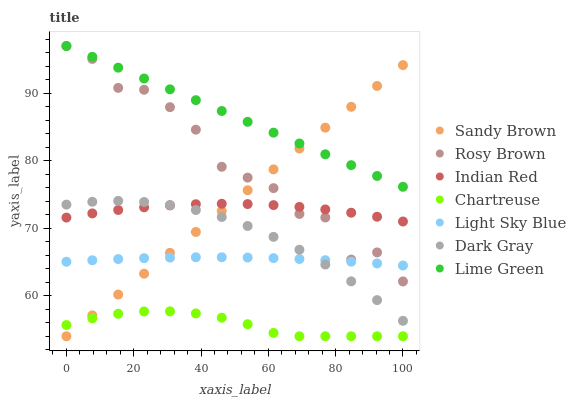Does Chartreuse have the minimum area under the curve?
Answer yes or no. Yes. Does Lime Green have the maximum area under the curve?
Answer yes or no. Yes. Does Rosy Brown have the minimum area under the curve?
Answer yes or no. No. Does Rosy Brown have the maximum area under the curve?
Answer yes or no. No. Is Lime Green the smoothest?
Answer yes or no. Yes. Is Rosy Brown the roughest?
Answer yes or no. Yes. Is Dark Gray the smoothest?
Answer yes or no. No. Is Dark Gray the roughest?
Answer yes or no. No. Does Chartreuse have the lowest value?
Answer yes or no. Yes. Does Rosy Brown have the lowest value?
Answer yes or no. No. Does Rosy Brown have the highest value?
Answer yes or no. Yes. Does Dark Gray have the highest value?
Answer yes or no. No. Is Chartreuse less than Light Sky Blue?
Answer yes or no. Yes. Is Indian Red greater than Chartreuse?
Answer yes or no. Yes. Does Rosy Brown intersect Lime Green?
Answer yes or no. Yes. Is Rosy Brown less than Lime Green?
Answer yes or no. No. Is Rosy Brown greater than Lime Green?
Answer yes or no. No. Does Chartreuse intersect Light Sky Blue?
Answer yes or no. No. 